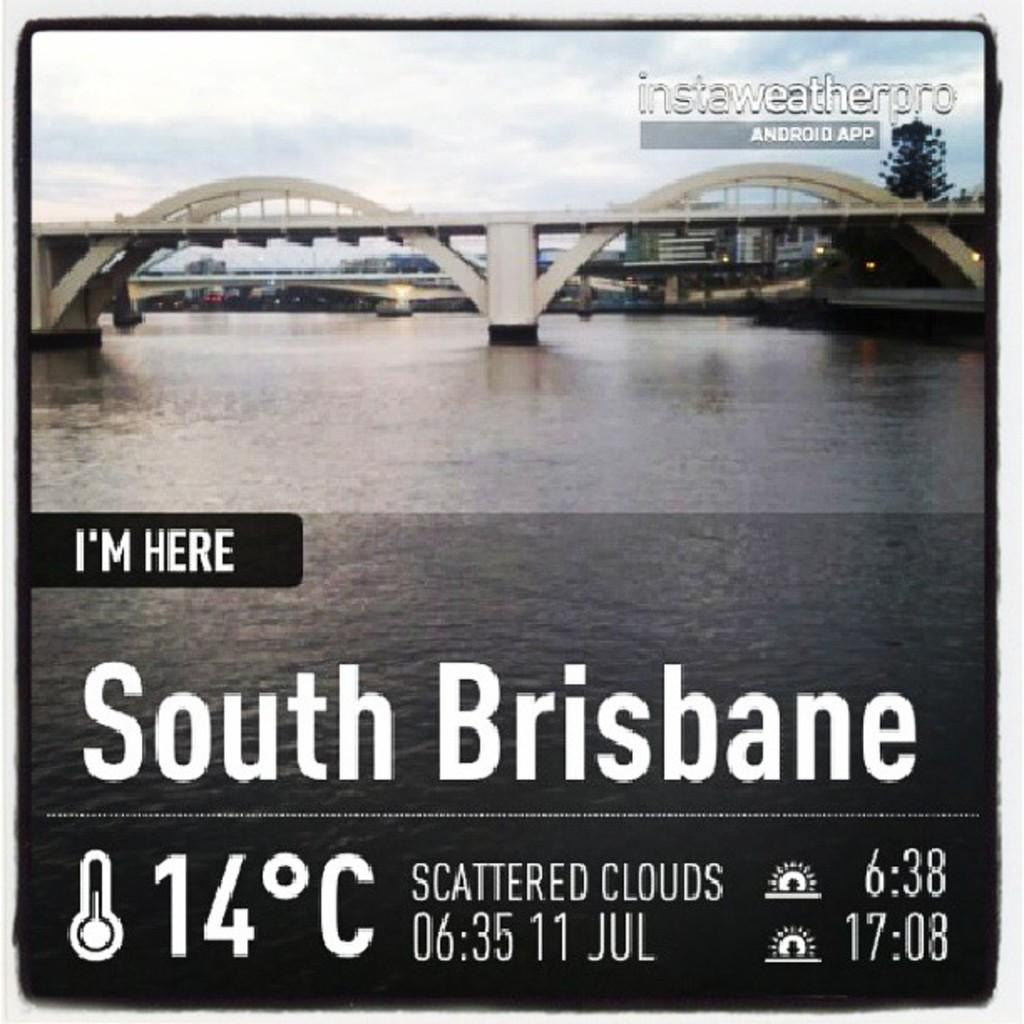Provide a one-sentence caption for the provided image. a bridge that has the location of South Brisbane on it. 